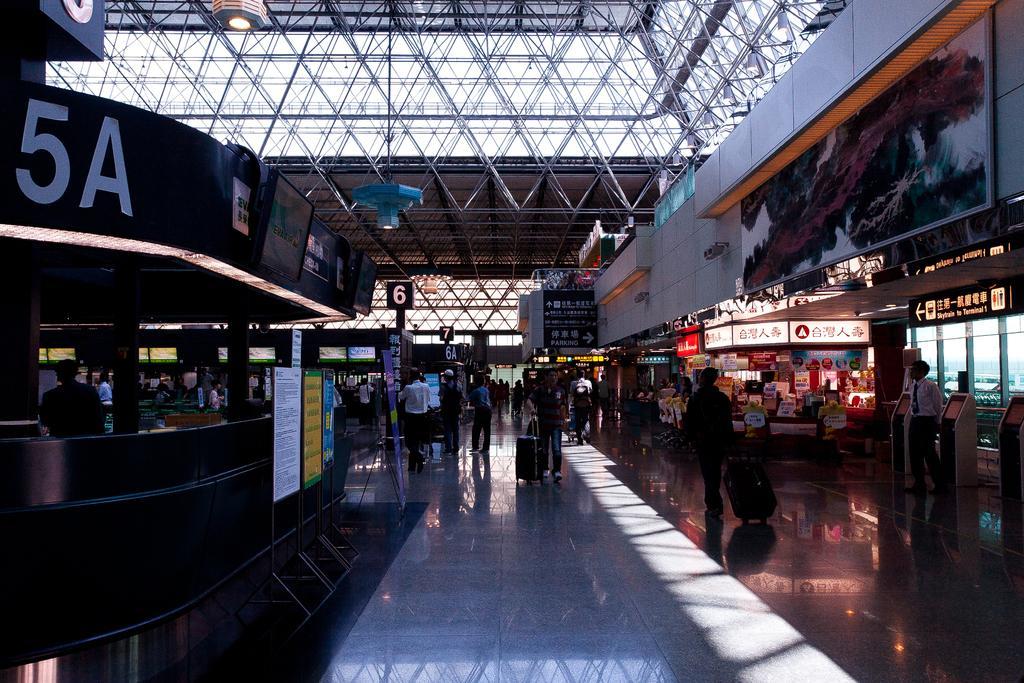Please provide a concise description of this image. In this picture we can see a few people on the floor. There are two people holding luggage bags and walking on the floor. We can see a few boards and a person on the left side. There are machines and a man on the right side. We can see some lights and a few steel objects on top. 